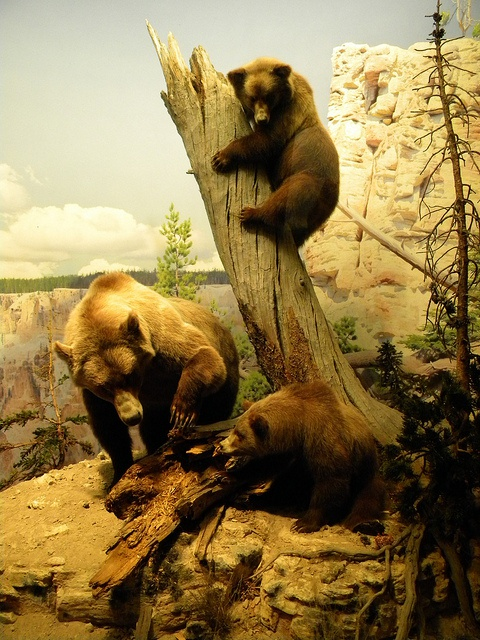Describe the objects in this image and their specific colors. I can see bear in darkgray, black, olive, maroon, and orange tones, bear in darkgray, black, maroon, and olive tones, and bear in darkgray, black, maroon, and olive tones in this image. 